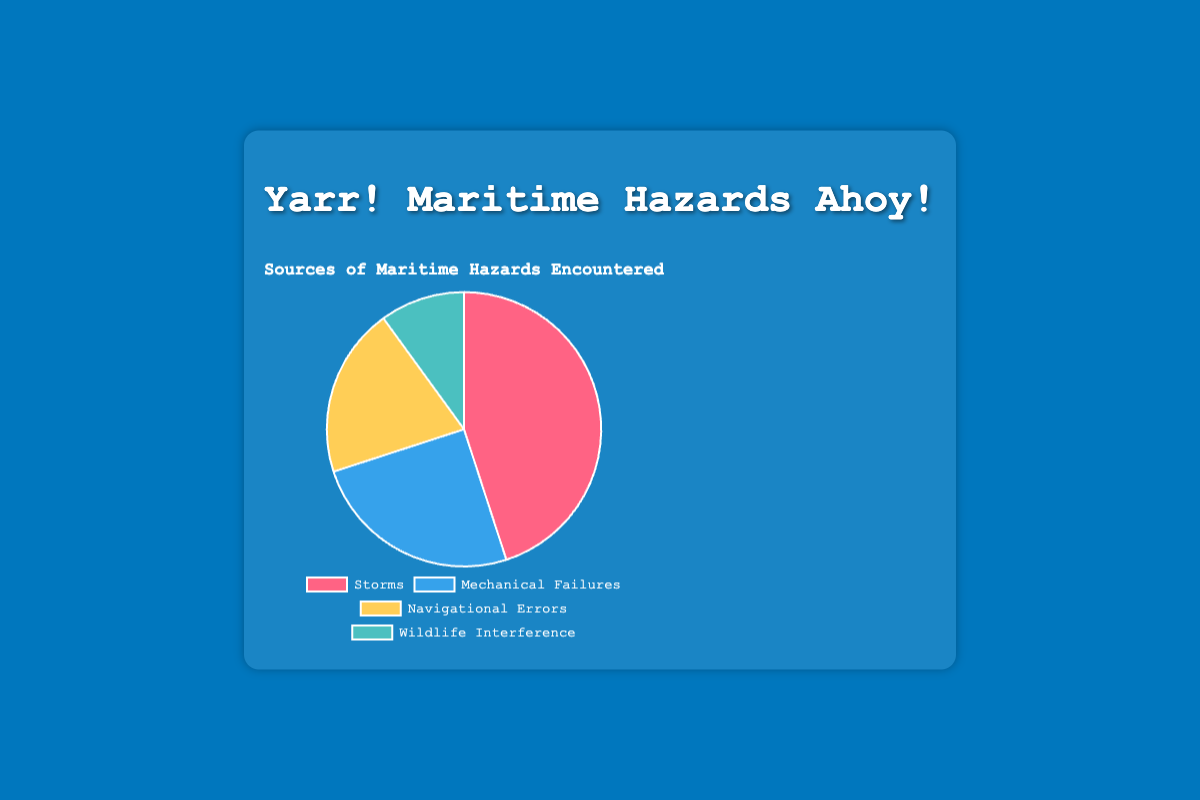Which category accounts for the highest percentage of maritime hazards? The pie chart shows various categories of maritime hazards. By observing the pie chart, we can see that "Storms" have the largest section.
Answer: Storms What is the combined percentage of hazards caused by Mechanical Failures and Navigational Errors? To find the combined percentage, add the percentages of Mechanical Failures (25%) and Navigational Errors (20%). So, the combined percentage is 25 + 20.
Answer: 45% How much more common are hazards from Storms compared to Wildlife Interference? The percentage for Storms is 45% and for Wildlife Interference is 10%. The difference is obtained by subtracting 10 from 45.
Answer: 35% Which hazard type has the smallest percentage of occurrences? The chart shows the distribution of hazards. The smallest section of the pie chart corresponds to "Wildlife Interference," which has a 10% occurrence rate.
Answer: Wildlife Interference Among Mechanical Failures, Navigational Errors, and Wildlife Interference, which one is most prevalent? By comparing the sections for Mechanical Failures (25%), Navigational Errors (20%), and Wildlife Interference (10%), Mechanical Failures have the largest section.
Answer: Mechanical Failures What percentage of hazards is not caused by Storms? To find the percentage not caused by Storms, subtract the percentage of Storms from 100%. 100% - 45% = 55%.
Answer: 55% If a ship faced 200 hazards last year, how many were due to Navigational Errors? To find this, multiply the total number of hazards (200) by the percentage due to Navigational Errors (20%). (200 * 0.20) = 40.
Answer: 40 Which hazard types together contribute half of the total hazards? We need to find hazard types whose percentages add up to approximately 50%. Combining Mechanical Failures (25%) and Navigational Errors (20%) gives 45%. Adding this to Wildlife Interference (10%) gives 55%. The first two sum to 45%, which is close enough for this context.
Answer: Mechanical Failures and Navigational Errors Is the percentage of hazards due to Mechanical Failures more or less than half of those due to Storms? The percentage due to Storms is 45%. Half of this is 22.5% (45/2). Comparing this with 25% for Mechanical Failures, we see it is slightly more.
Answer: More What are the colors representing Storms and Wildlife Interference on the pie chart? In the chart, the color representing Storms is red and the color representing Wildlife Interference is green.
Answer: Red and green 